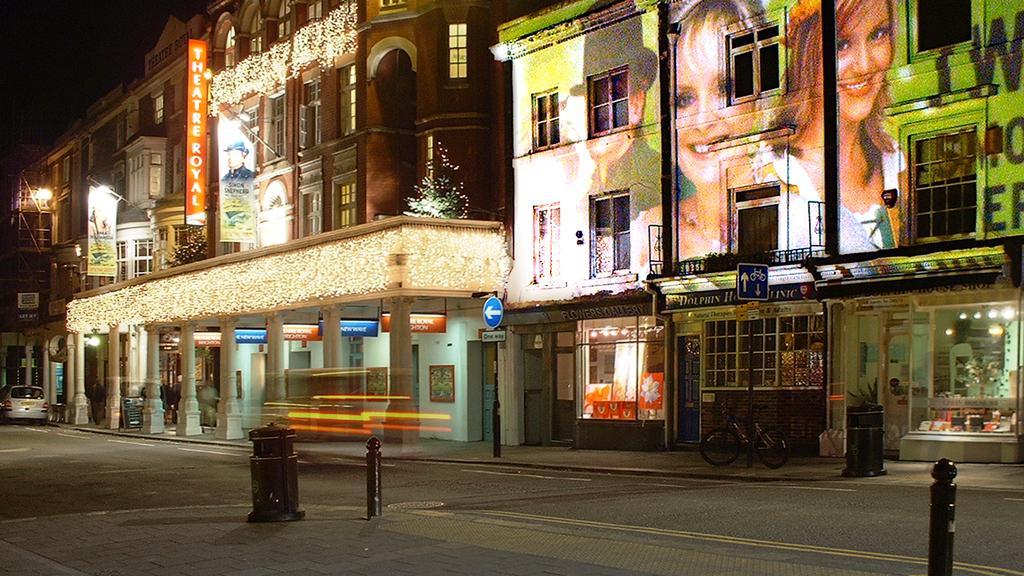Describe this image in one or two sentences. In this image I can see number buildings, windows, few boards, a bicycle, few doors and on these boards I can see something is written. Here I can see faces of few people. 